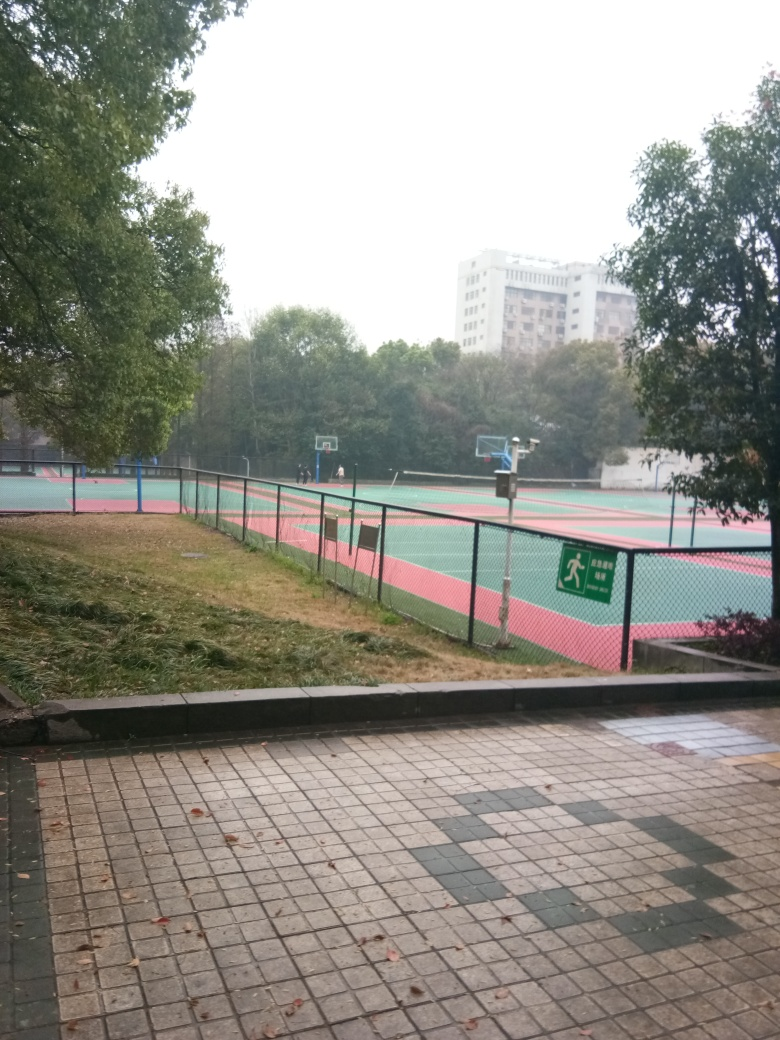What's the weather like in this picture? The weather looks overcast and gloomy with a cloudy sky, and the ground appears to be wet, which might indicate recent rain. 